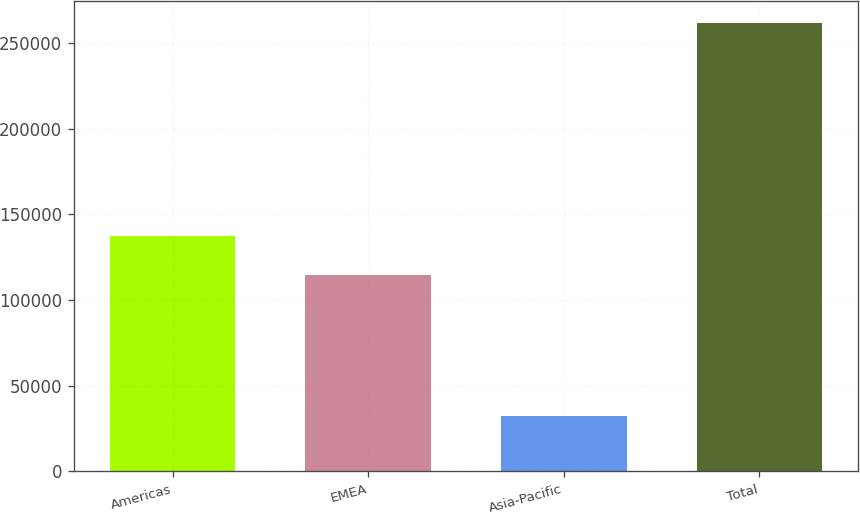<chart> <loc_0><loc_0><loc_500><loc_500><bar_chart><fcel>Americas<fcel>EMEA<fcel>Asia-Pacific<fcel>Total<nl><fcel>137364<fcel>114446<fcel>32502<fcel>261682<nl></chart> 